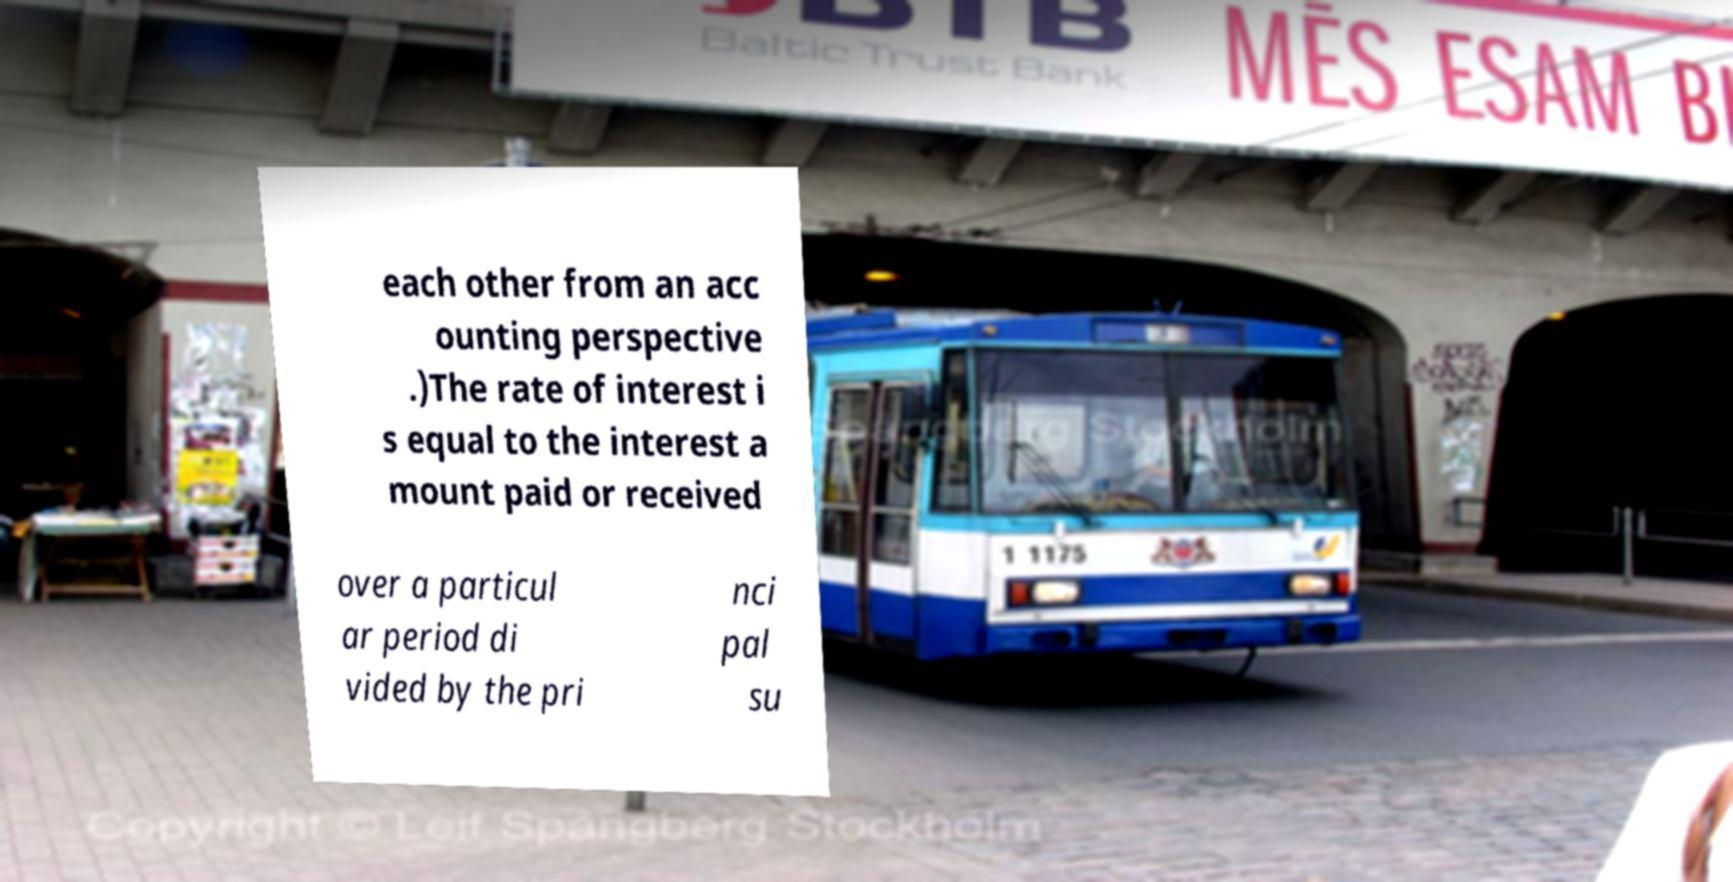Please identify and transcribe the text found in this image. each other from an acc ounting perspective .)The rate of interest i s equal to the interest a mount paid or received over a particul ar period di vided by the pri nci pal su 